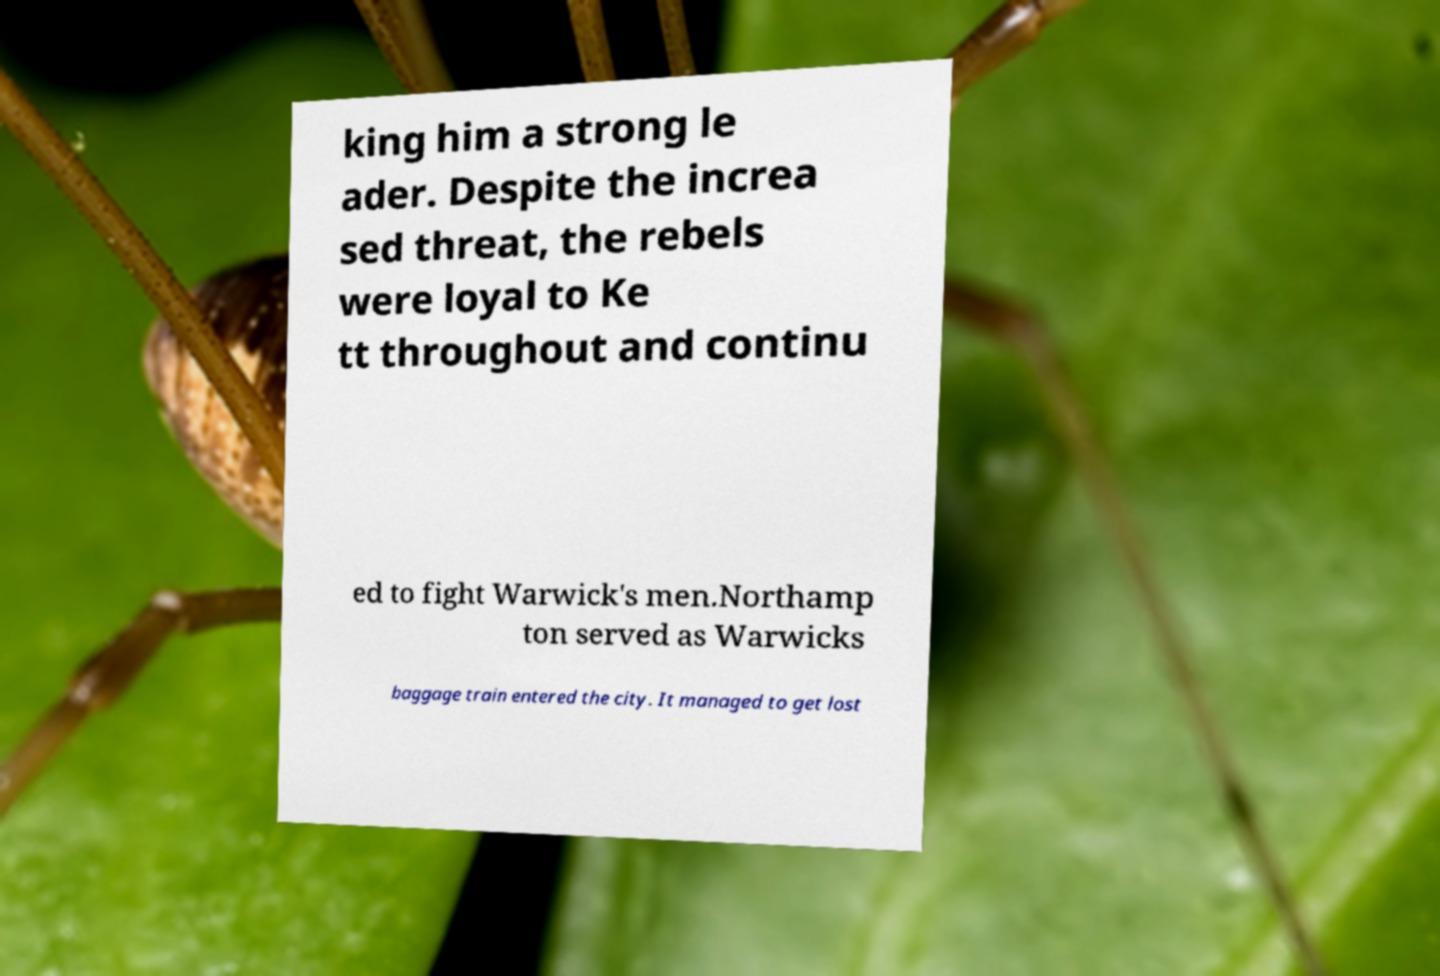Please read and relay the text visible in this image. What does it say? king him a strong le ader. Despite the increa sed threat, the rebels were loyal to Ke tt throughout and continu ed to fight Warwick's men.Northamp ton served as Warwicks baggage train entered the city. It managed to get lost 